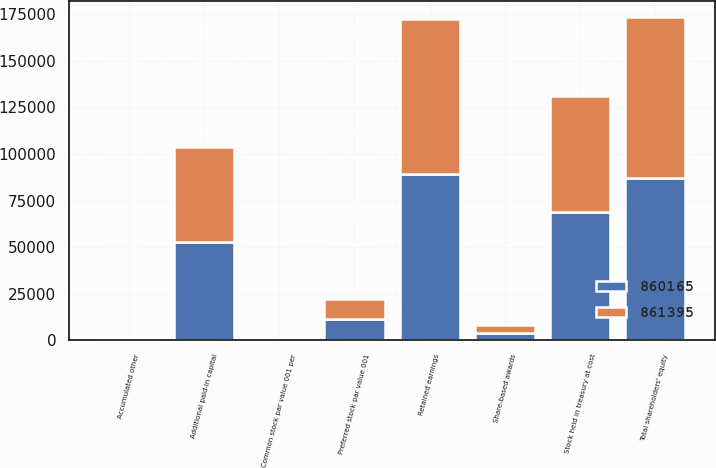Convert chart. <chart><loc_0><loc_0><loc_500><loc_500><stacked_bar_chart><ecel><fcel>Preferred stock par value 001<fcel>Common stock par value 001 per<fcel>Share-based awards<fcel>Additional paid-in capital<fcel>Retained earnings<fcel>Accumulated other<fcel>Stock held in treasury at cost<fcel>Total shareholders' equity<nl><fcel>860165<fcel>11203<fcel>9<fcel>3914<fcel>52638<fcel>89039<fcel>1216<fcel>68694<fcel>86893<nl><fcel>861395<fcel>11200<fcel>9<fcel>4151<fcel>51340<fcel>83386<fcel>718<fcel>62640<fcel>86728<nl></chart> 